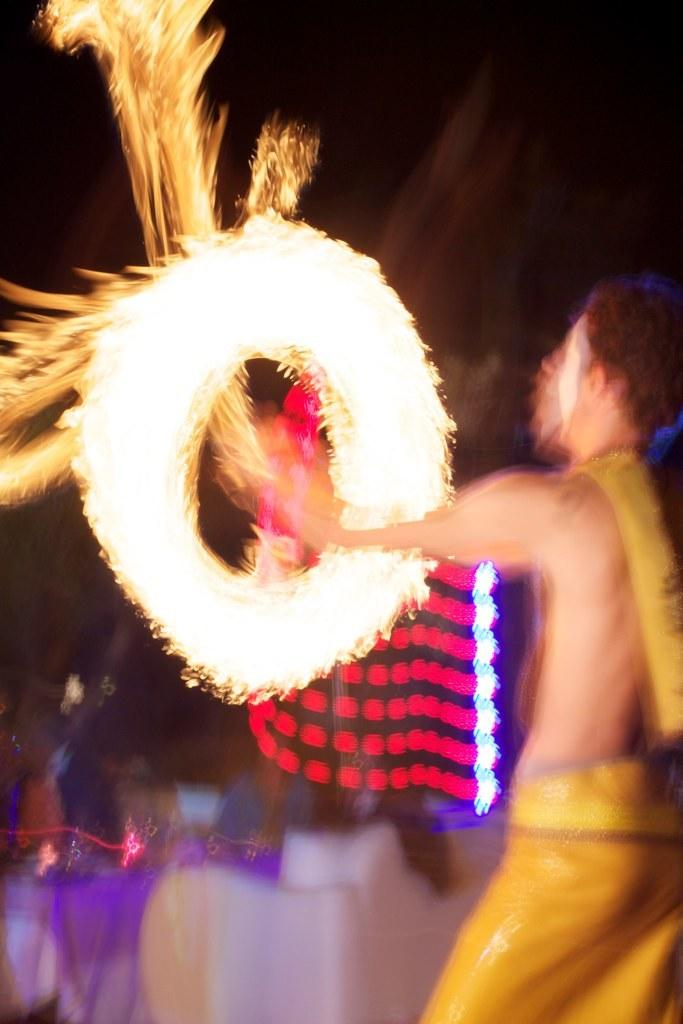What is the main subject of the image? The main subject of the image is a man. What is the man doing in the image? The man is playing with fire in the image. What can be seen in the background of the image? There are lights visible in the background of the image. How many icicles are hanging from the man's hat in the image? There are no icicles present in the image. What type of trade is the man involved in, as depicted in the image? The image does not depict the man being involved in any trade. 